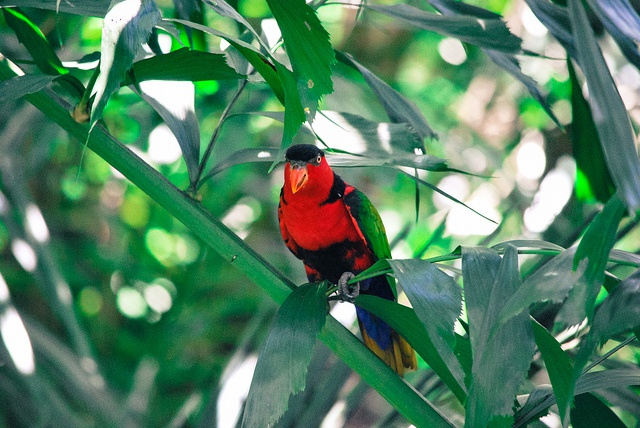Describe the objects in this image and their specific colors. I can see a bird in darkgreen, black, and brown tones in this image. 